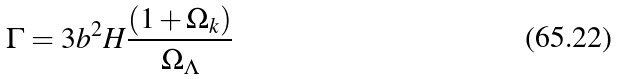Convert formula to latex. <formula><loc_0><loc_0><loc_500><loc_500>\Gamma = 3 b ^ { 2 } H \frac { ( 1 + \Omega _ { k } ) } { \Omega _ { \Lambda } }</formula> 